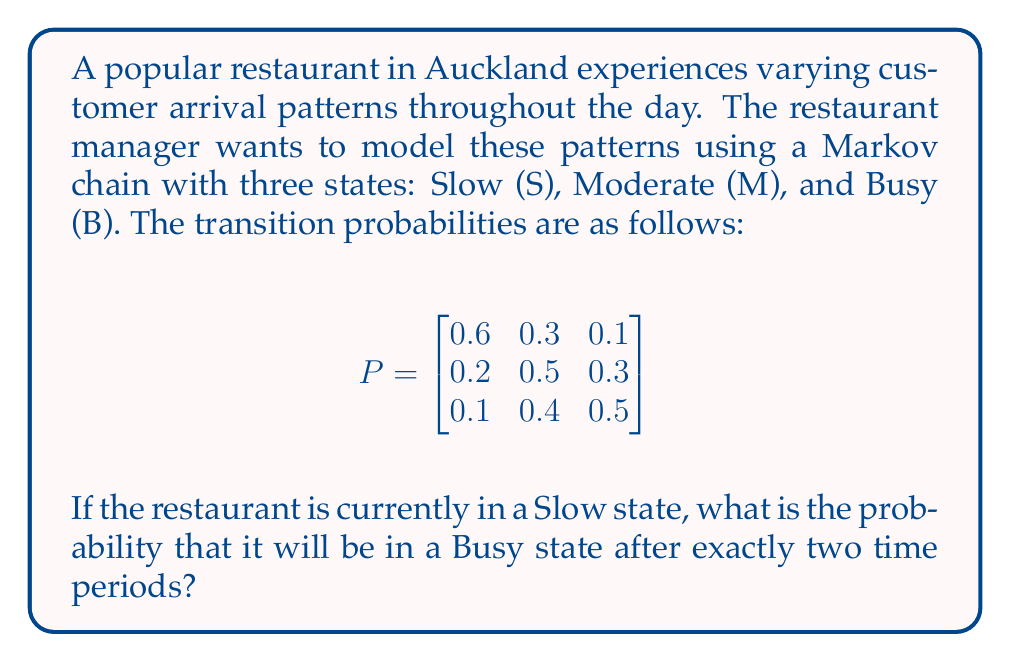What is the answer to this math problem? To solve this problem, we need to use the Chapman-Kolmogorov equations and calculate the two-step transition probability from Slow (S) to Busy (B). Let's break it down step-by-step:

1. We need to calculate $P^2$, which represents the two-step transition matrix:

   $$P^2 = P \times P$$

2. To find the element we're interested in (S to B after two steps), we'll focus on the first row, third column of $P^2$.

3. Let's multiply the matrices:

   $$
   \begin{bmatrix}
   0.6 & 0.3 & 0.1 \\
   0.2 & 0.5 & 0.3 \\
   0.1 & 0.4 & 0.5
   \end{bmatrix}
   \times
   \begin{bmatrix}
   0.6 & 0.3 & 0.1 \\
   0.2 & 0.5 & 0.3 \\
   0.1 & 0.4 & 0.5
   \end{bmatrix}
   $$

4. For the element we need (first row, third column), we calculate:

   $$(0.6 \times 0.1) + (0.3 \times 0.3) + (0.1 \times 0.5)$$

5. Let's compute each term:
   - $0.6 \times 0.1 = 0.06$
   - $0.3 \times 0.3 = 0.09$
   - $0.1 \times 0.5 = 0.05$

6. Sum up the terms:

   $$0.06 + 0.09 + 0.05 = 0.20$$

Therefore, the probability of the restaurant being in a Busy state after exactly two time periods, given that it starts in a Slow state, is 0.20 or 20%.
Answer: 0.20 